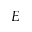Convert formula to latex. <formula><loc_0><loc_0><loc_500><loc_500>E</formula> 